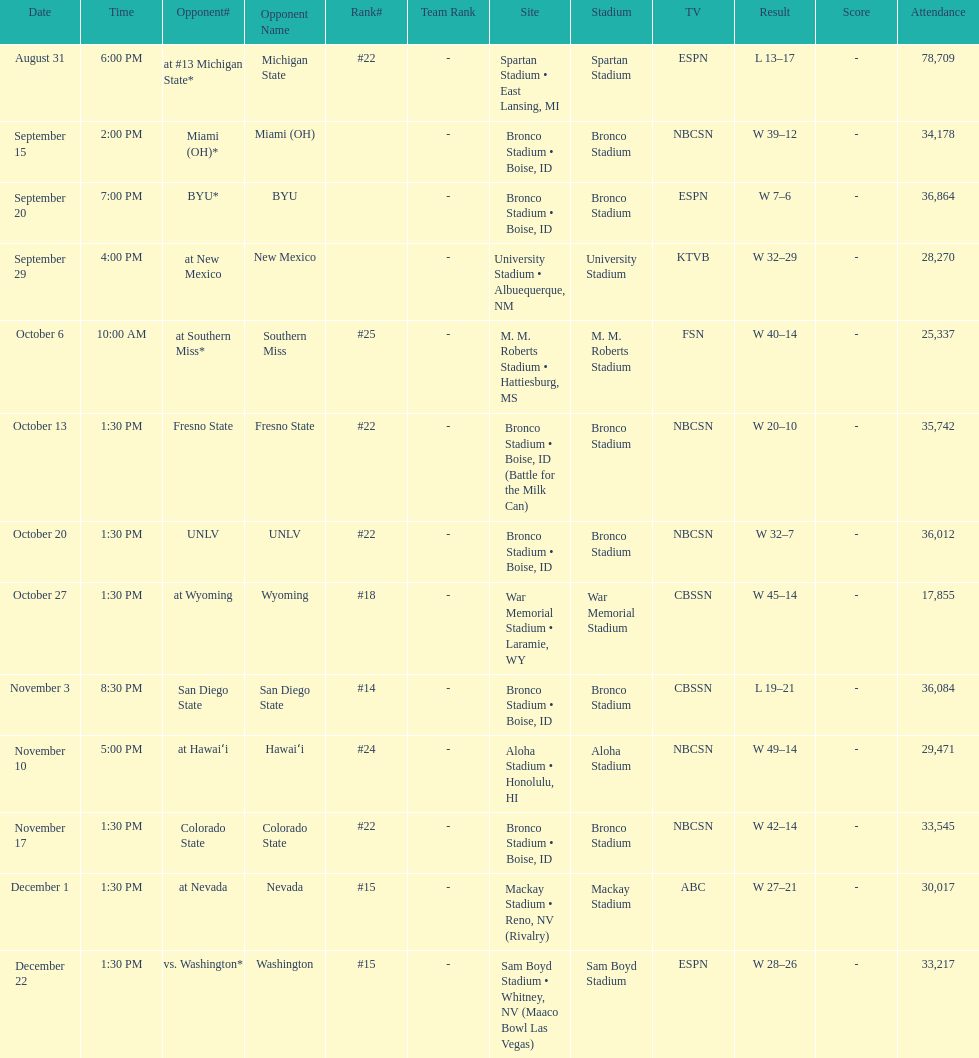Add up the total number of points scored in the last wins for boise state. 146. 